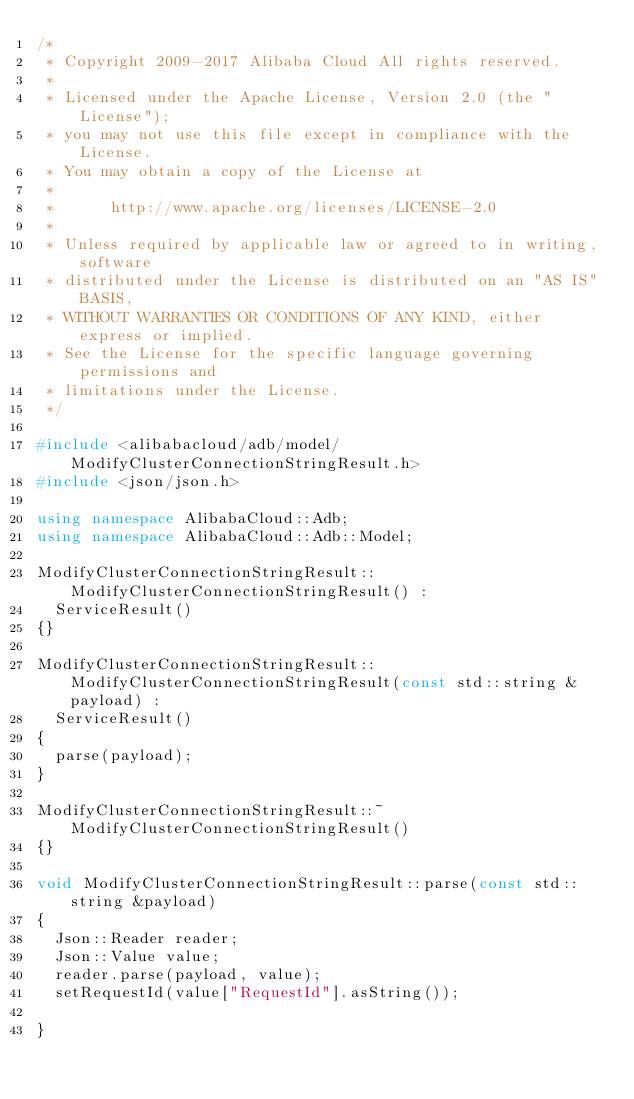Convert code to text. <code><loc_0><loc_0><loc_500><loc_500><_C++_>/*
 * Copyright 2009-2017 Alibaba Cloud All rights reserved.
 * 
 * Licensed under the Apache License, Version 2.0 (the "License");
 * you may not use this file except in compliance with the License.
 * You may obtain a copy of the License at
 * 
 *      http://www.apache.org/licenses/LICENSE-2.0
 * 
 * Unless required by applicable law or agreed to in writing, software
 * distributed under the License is distributed on an "AS IS" BASIS,
 * WITHOUT WARRANTIES OR CONDITIONS OF ANY KIND, either express or implied.
 * See the License for the specific language governing permissions and
 * limitations under the License.
 */

#include <alibabacloud/adb/model/ModifyClusterConnectionStringResult.h>
#include <json/json.h>

using namespace AlibabaCloud::Adb;
using namespace AlibabaCloud::Adb::Model;

ModifyClusterConnectionStringResult::ModifyClusterConnectionStringResult() :
	ServiceResult()
{}

ModifyClusterConnectionStringResult::ModifyClusterConnectionStringResult(const std::string &payload) :
	ServiceResult()
{
	parse(payload);
}

ModifyClusterConnectionStringResult::~ModifyClusterConnectionStringResult()
{}

void ModifyClusterConnectionStringResult::parse(const std::string &payload)
{
	Json::Reader reader;
	Json::Value value;
	reader.parse(payload, value);
	setRequestId(value["RequestId"].asString());

}

</code> 